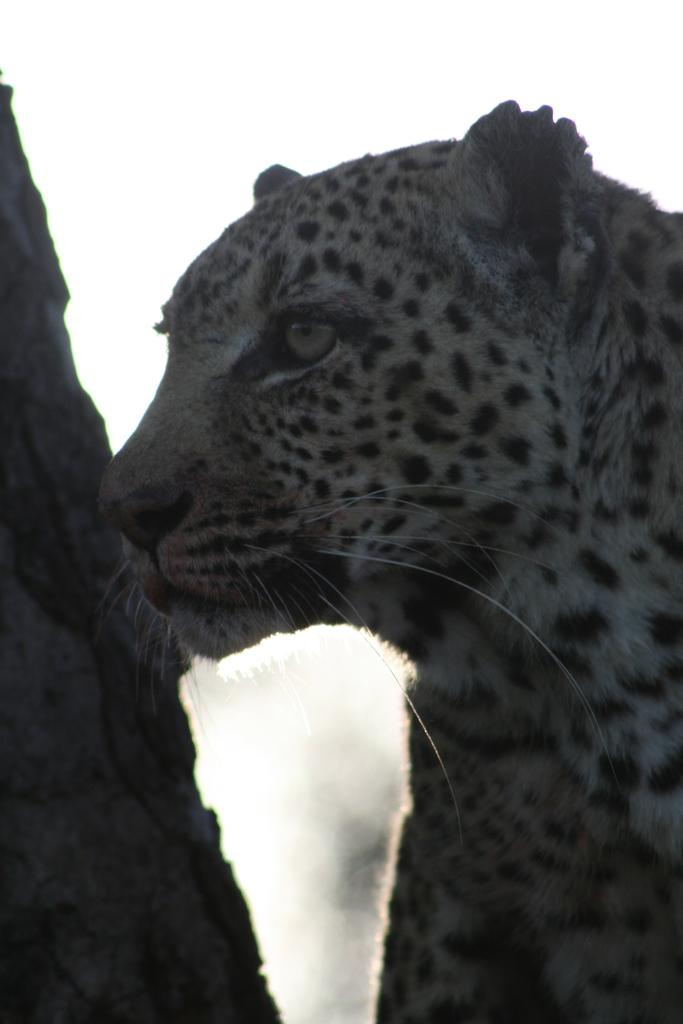What animal is present in the image? There is a tiger in the image. What can be seen behind the tiger? There is a trunk of a tree behind the tiger. What type of doctor is examining the tiger in the image? There is no doctor present in the image; it only features a tiger and a tree trunk. 